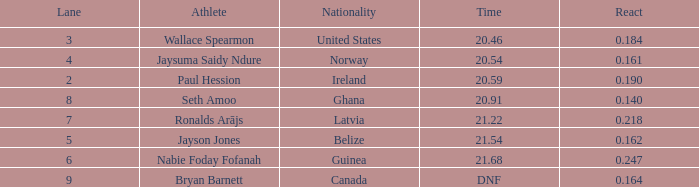Who is the sportsman when reaction time is Bryan Barnett. 